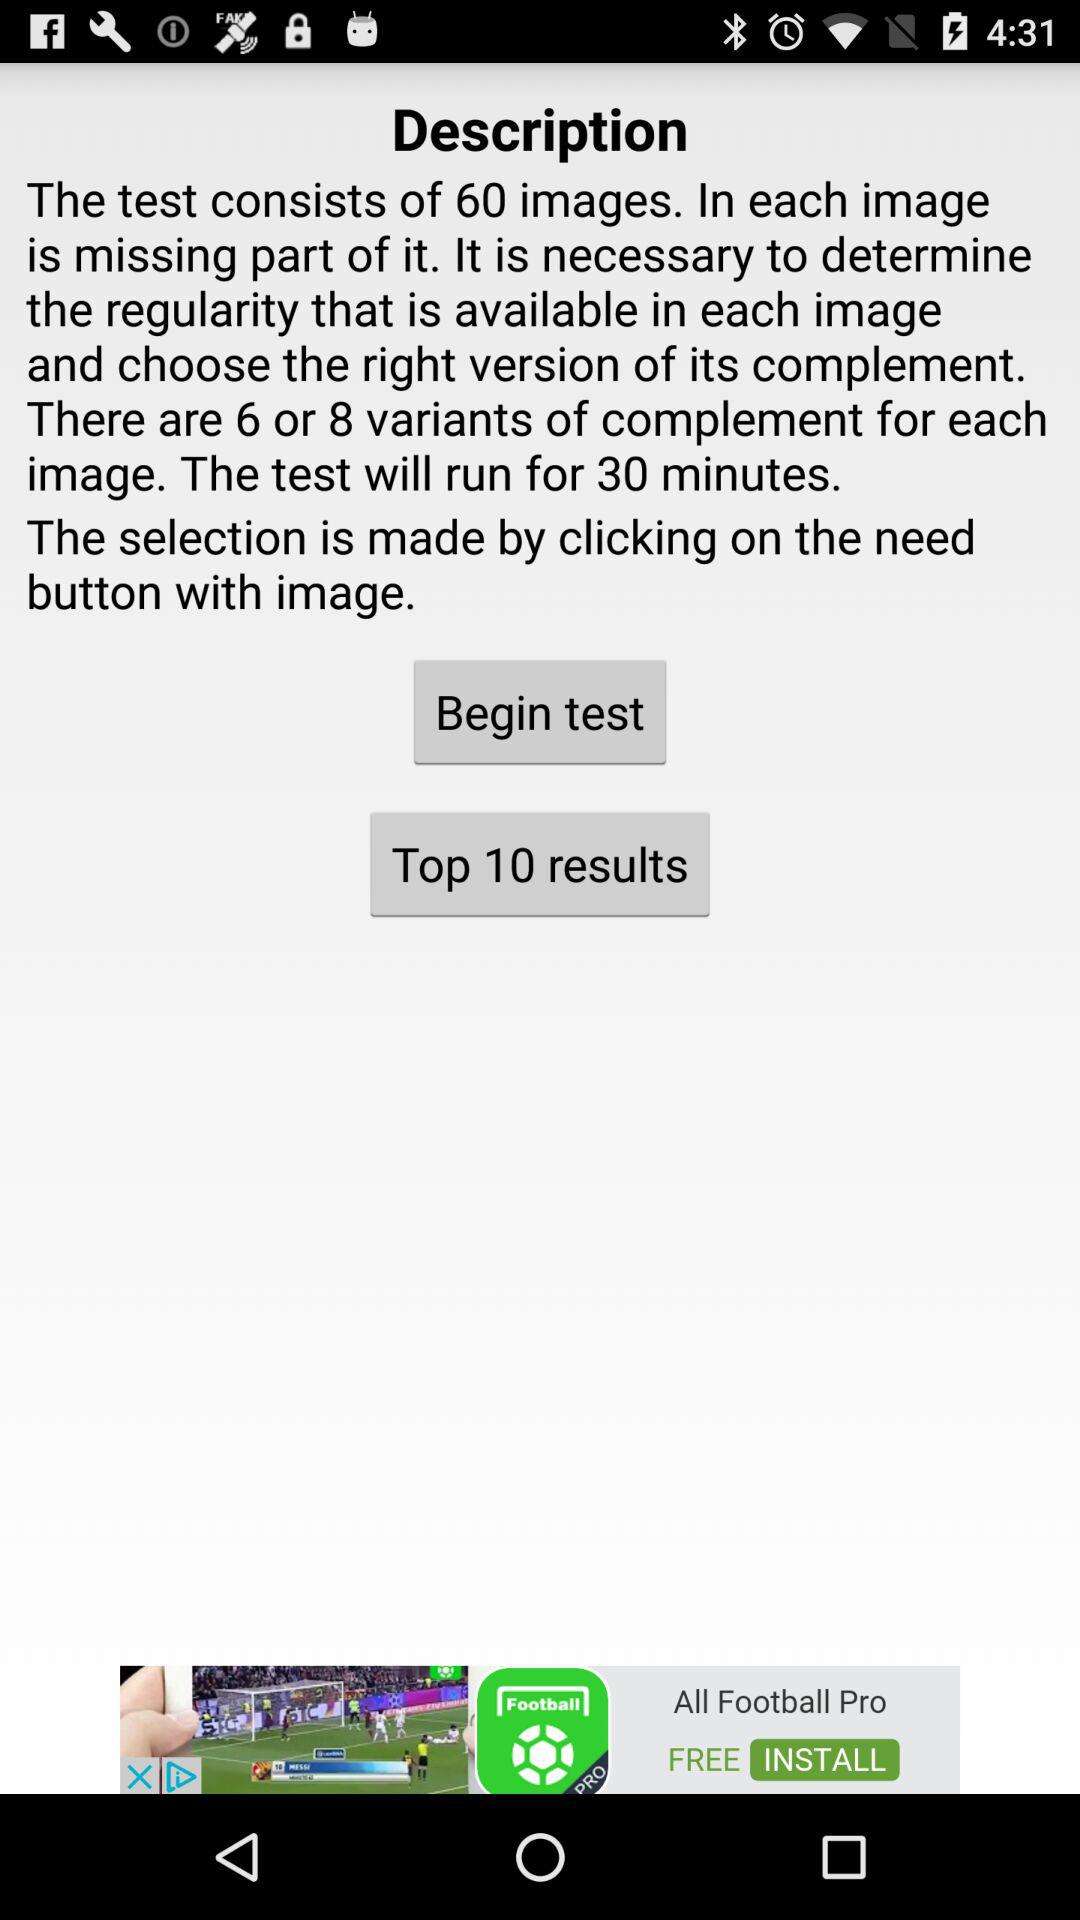How many images are there in the test? There are 60 images. 